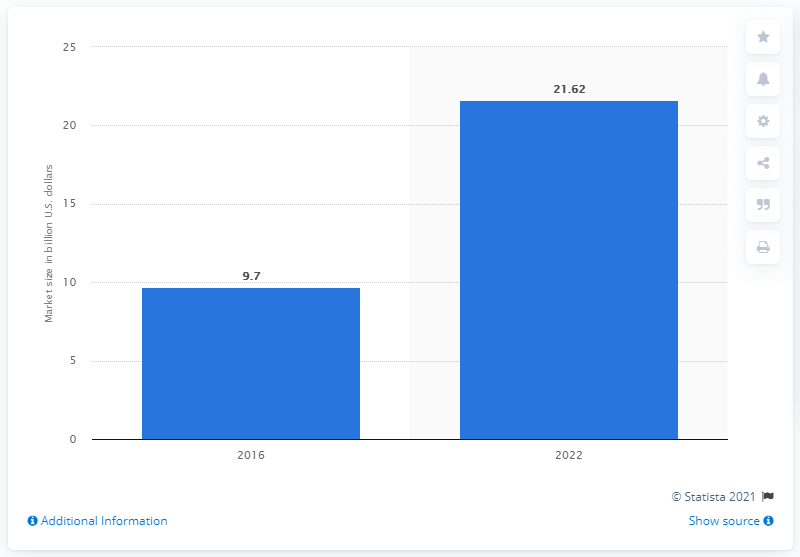Mention a couple of crucial points in this snapshot. The estimated value of the global remote sensing services market between 2017 and 2022 is expected to be approximately 21.62. 